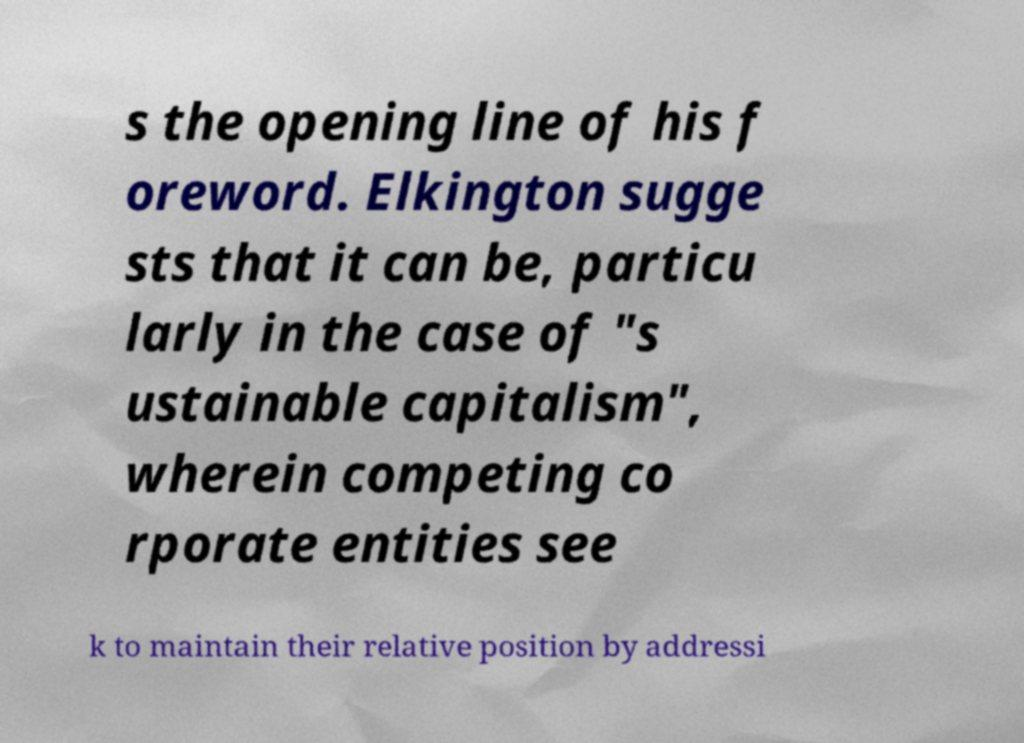There's text embedded in this image that I need extracted. Can you transcribe it verbatim? s the opening line of his f oreword. Elkington sugge sts that it can be, particu larly in the case of "s ustainable capitalism", wherein competing co rporate entities see k to maintain their relative position by addressi 